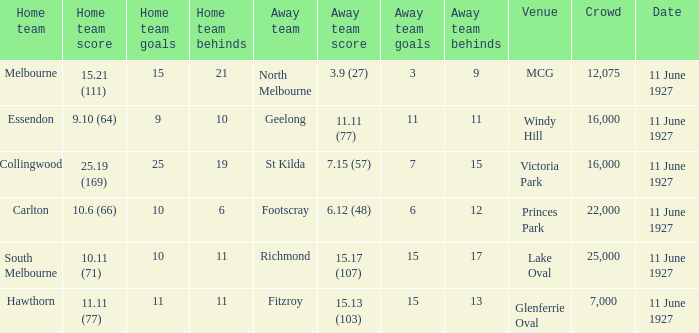What was the total number of people present in all the crowds at the mcg venue? 12075.0. 